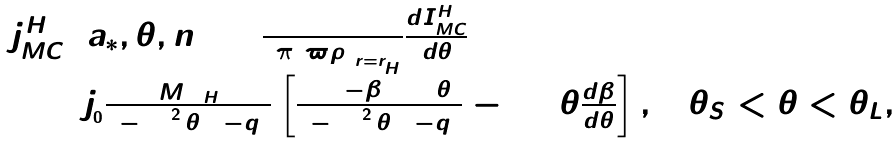Convert formula to latex. <formula><loc_0><loc_0><loc_500><loc_500>\begin{array} { l } j _ { M C } ^ { H } \left ( { a _ { * } , \theta , n } \right ) = \frac { 1 } { 2 \pi \left ( { \varpi \rho } \right ) _ { r = r _ { _ { H } } } } \frac { d I _ { M C } ^ { H } } { d \theta } \\ \quad = j _ { _ { 0 } } \frac { M \Omega _ { H } } { 2 - \sin ^ { 2 } \theta \left ( { 1 - q } \right ) } \left [ { \frac { 4 \left ( { 1 - \beta } \right ) \cos \theta } { 2 - \sin ^ { 2 } \theta \left ( { 1 - q } \right ) } - \sin \theta \frac { d \beta } { d \theta } } \right ] , \quad \theta _ { S } < \theta < \theta _ { L } , \end{array}</formula> 